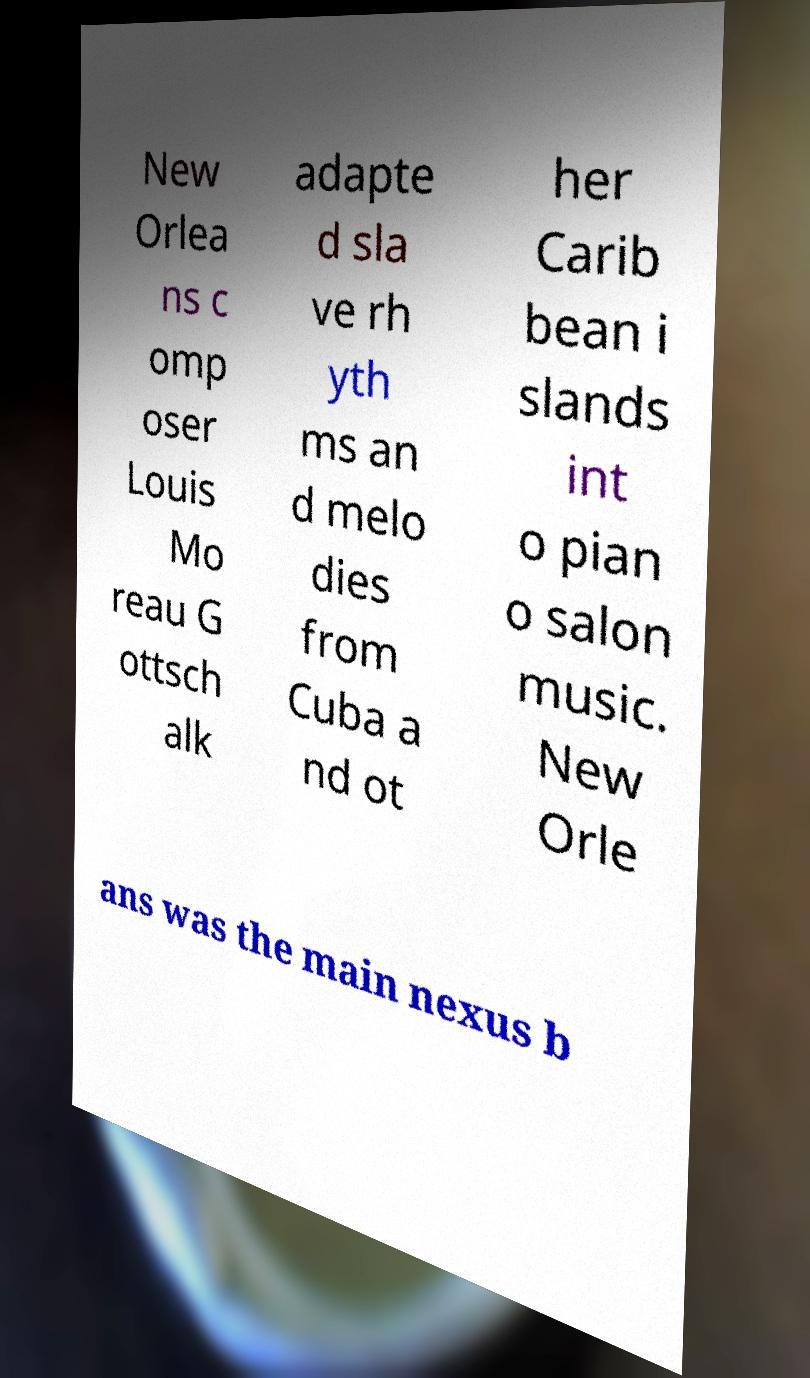Can you read and provide the text displayed in the image?This photo seems to have some interesting text. Can you extract and type it out for me? New Orlea ns c omp oser Louis Mo reau G ottsch alk adapte d sla ve rh yth ms an d melo dies from Cuba a nd ot her Carib bean i slands int o pian o salon music. New Orle ans was the main nexus b 